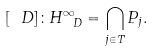<formula> <loc_0><loc_0><loc_500><loc_500>[ \ D ] \colon H _ { \ D } ^ { \infty } = \bigcap _ { j \in T } P _ { j } .</formula> 